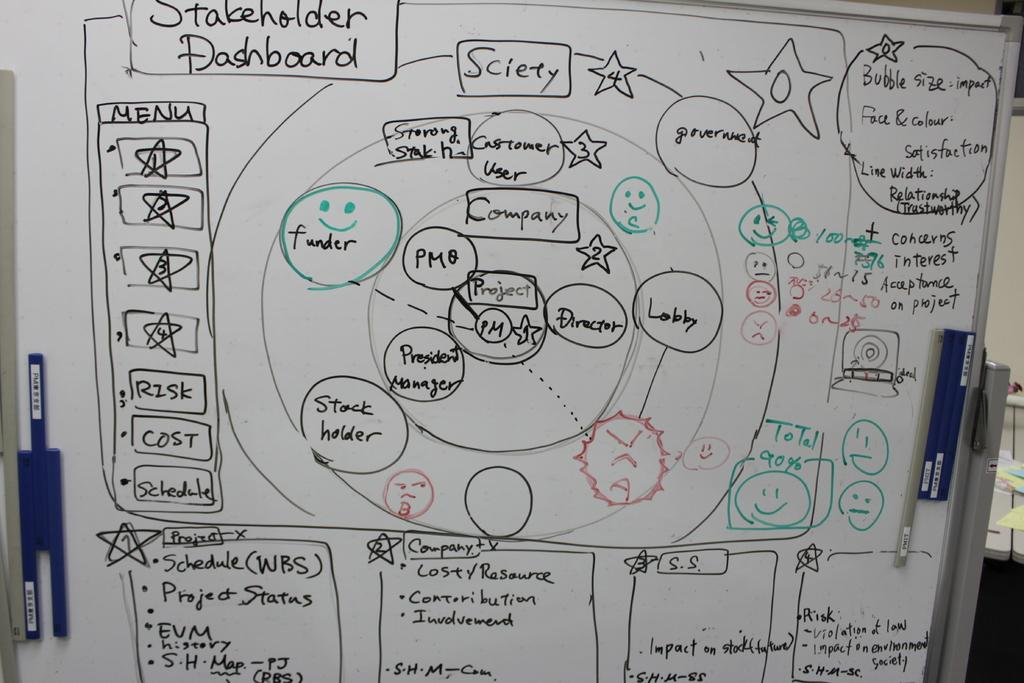Provide a one-sentence caption for the provided image. A white board contains ideas for the stakeholder dashboard. 